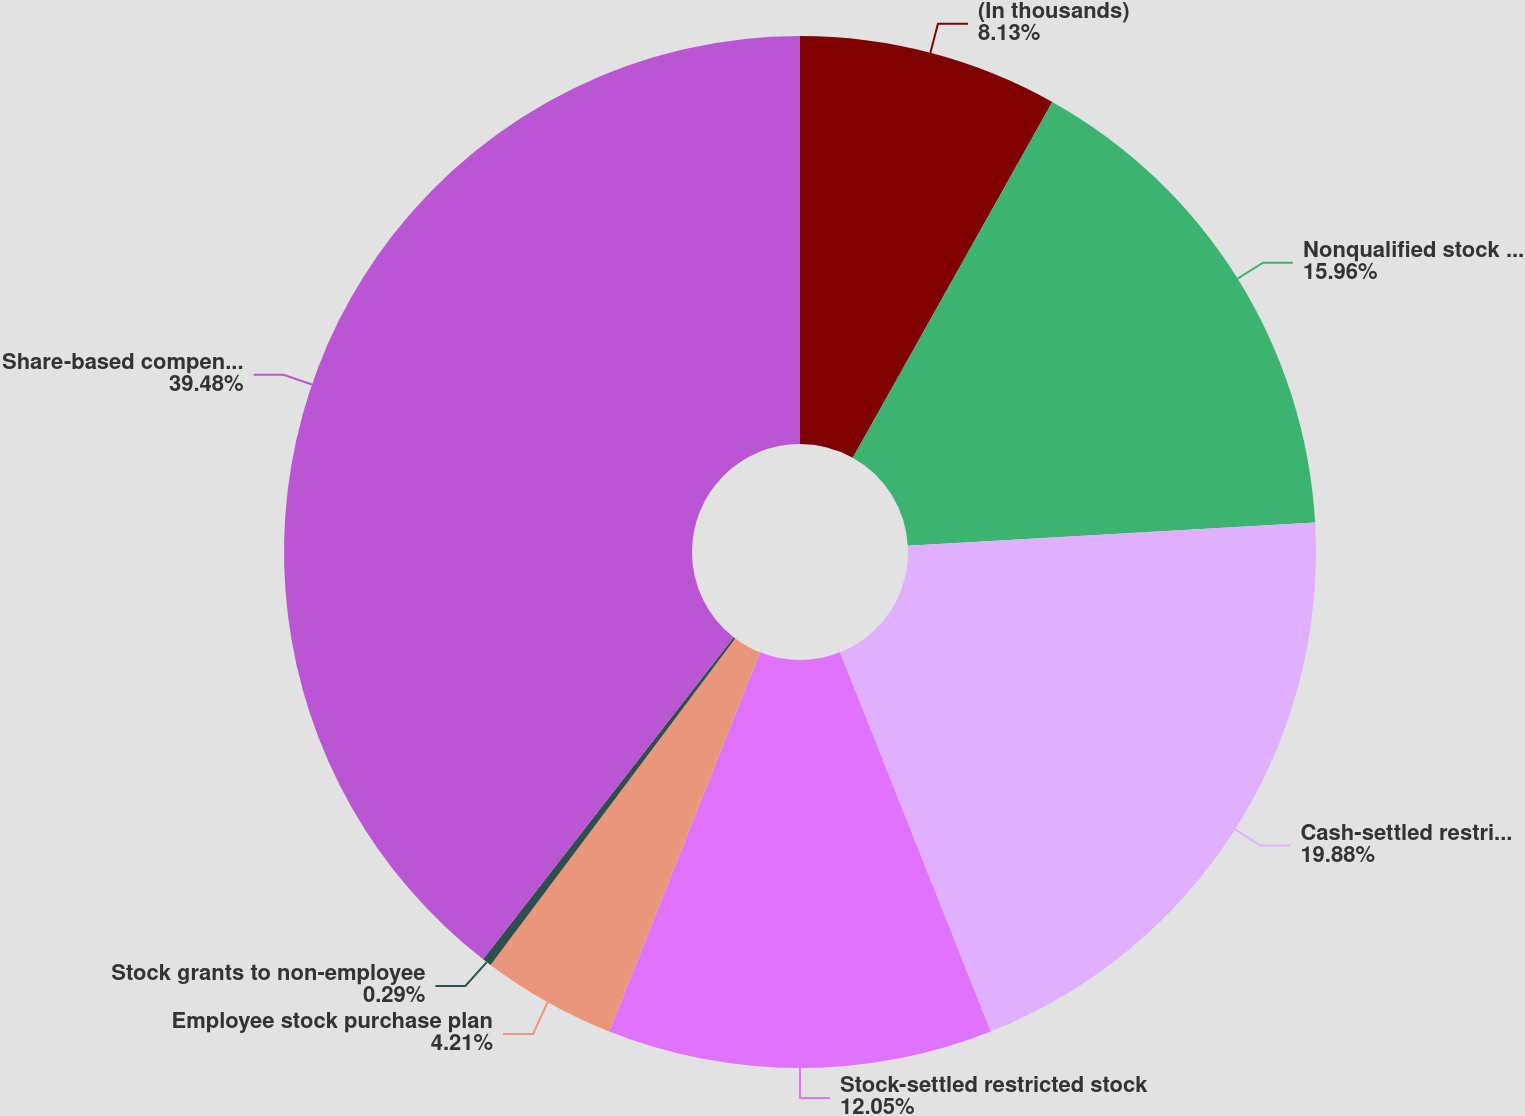Convert chart. <chart><loc_0><loc_0><loc_500><loc_500><pie_chart><fcel>(In thousands)<fcel>Nonqualified stock options<fcel>Cash-settled restricted stock<fcel>Stock-settled restricted stock<fcel>Employee stock purchase plan<fcel>Stock grants to non-employee<fcel>Share-based compensation<nl><fcel>8.13%<fcel>15.96%<fcel>19.88%<fcel>12.05%<fcel>4.21%<fcel>0.29%<fcel>39.47%<nl></chart> 